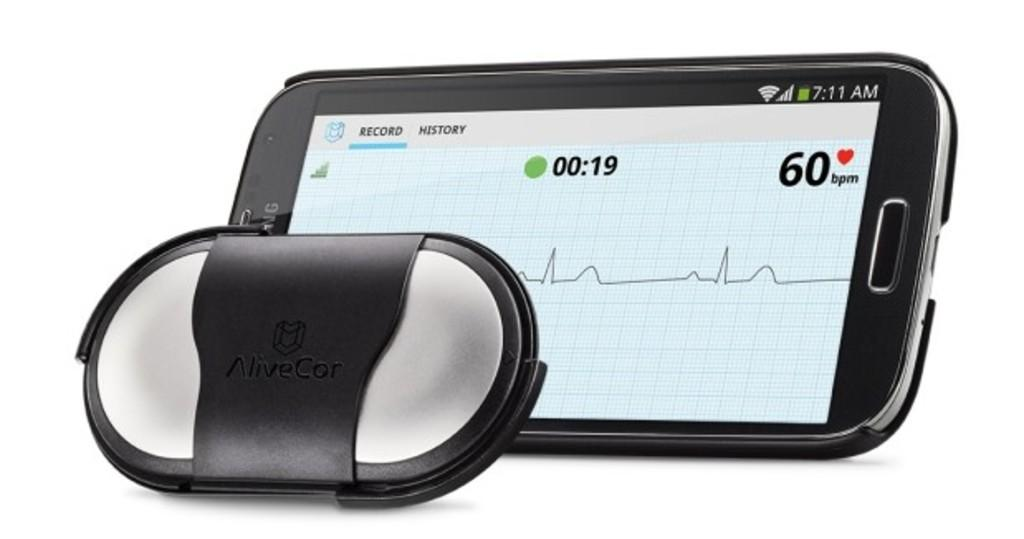<image>
Write a terse but informative summary of the picture. The alivecor device displays a record of Bpm. 